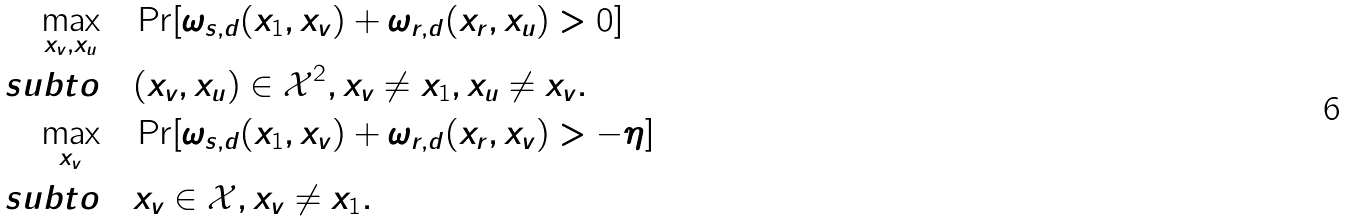Convert formula to latex. <formula><loc_0><loc_0><loc_500><loc_500>\underset { x _ { v } , x _ { u } } { \max } \quad & \Pr [ \omega _ { s , d } ( x _ { 1 } , x _ { v } ) + \omega _ { r , d } ( x _ { r } , x _ { u } ) > 0 ] \\ \ s u b t o \quad & ( x _ { v } , x _ { u } ) \in \mathcal { X } ^ { 2 } , x _ { v } \neq x _ { 1 } , x _ { u } \neq x _ { v } . \\ \underset { x _ { v } } { \max } \quad & \Pr [ \omega _ { s , d } ( x _ { 1 } , x _ { v } ) + \omega _ { r , d } ( x _ { r } , x _ { v } ) > - \eta ] \\ \ s u b t o \quad & x _ { v } \in \mathcal { X } , x _ { v } \neq x _ { 1 } .</formula> 